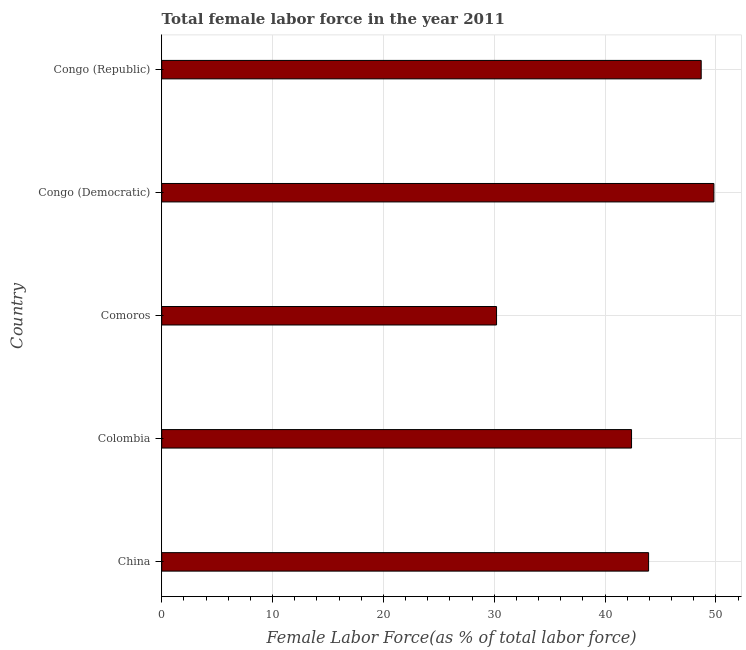Does the graph contain grids?
Your response must be concise. Yes. What is the title of the graph?
Offer a very short reply. Total female labor force in the year 2011. What is the label or title of the X-axis?
Give a very brief answer. Female Labor Force(as % of total labor force). What is the label or title of the Y-axis?
Your response must be concise. Country. What is the total female labor force in China?
Make the answer very short. 43.92. Across all countries, what is the maximum total female labor force?
Give a very brief answer. 49.81. Across all countries, what is the minimum total female labor force?
Keep it short and to the point. 30.21. In which country was the total female labor force maximum?
Provide a succinct answer. Congo (Democratic). In which country was the total female labor force minimum?
Offer a terse response. Comoros. What is the sum of the total female labor force?
Your answer should be compact. 214.99. What is the difference between the total female labor force in Colombia and Congo (Republic)?
Offer a terse response. -6.28. What is the average total female labor force per country?
Your response must be concise. 43. What is the median total female labor force?
Make the answer very short. 43.92. What is the ratio of the total female labor force in Comoros to that in Congo (Republic)?
Make the answer very short. 0.62. Is the total female labor force in Colombia less than that in Comoros?
Make the answer very short. No. What is the difference between the highest and the second highest total female labor force?
Make the answer very short. 1.14. What is the difference between the highest and the lowest total female labor force?
Offer a very short reply. 19.61. In how many countries, is the total female labor force greater than the average total female labor force taken over all countries?
Offer a terse response. 3. What is the difference between two consecutive major ticks on the X-axis?
Ensure brevity in your answer.  10. What is the Female Labor Force(as % of total labor force) in China?
Your answer should be compact. 43.92. What is the Female Labor Force(as % of total labor force) in Colombia?
Your answer should be compact. 42.38. What is the Female Labor Force(as % of total labor force) of Comoros?
Offer a very short reply. 30.21. What is the Female Labor Force(as % of total labor force) in Congo (Democratic)?
Offer a terse response. 49.81. What is the Female Labor Force(as % of total labor force) in Congo (Republic)?
Give a very brief answer. 48.67. What is the difference between the Female Labor Force(as % of total labor force) in China and Colombia?
Offer a terse response. 1.54. What is the difference between the Female Labor Force(as % of total labor force) in China and Comoros?
Keep it short and to the point. 13.72. What is the difference between the Female Labor Force(as % of total labor force) in China and Congo (Democratic)?
Provide a succinct answer. -5.89. What is the difference between the Female Labor Force(as % of total labor force) in China and Congo (Republic)?
Your answer should be compact. -4.75. What is the difference between the Female Labor Force(as % of total labor force) in Colombia and Comoros?
Give a very brief answer. 12.18. What is the difference between the Female Labor Force(as % of total labor force) in Colombia and Congo (Democratic)?
Offer a very short reply. -7.43. What is the difference between the Female Labor Force(as % of total labor force) in Colombia and Congo (Republic)?
Your response must be concise. -6.28. What is the difference between the Female Labor Force(as % of total labor force) in Comoros and Congo (Democratic)?
Make the answer very short. -19.61. What is the difference between the Female Labor Force(as % of total labor force) in Comoros and Congo (Republic)?
Provide a succinct answer. -18.46. What is the difference between the Female Labor Force(as % of total labor force) in Congo (Democratic) and Congo (Republic)?
Give a very brief answer. 1.14. What is the ratio of the Female Labor Force(as % of total labor force) in China to that in Colombia?
Ensure brevity in your answer.  1.04. What is the ratio of the Female Labor Force(as % of total labor force) in China to that in Comoros?
Your answer should be compact. 1.45. What is the ratio of the Female Labor Force(as % of total labor force) in China to that in Congo (Democratic)?
Provide a short and direct response. 0.88. What is the ratio of the Female Labor Force(as % of total labor force) in China to that in Congo (Republic)?
Keep it short and to the point. 0.9. What is the ratio of the Female Labor Force(as % of total labor force) in Colombia to that in Comoros?
Provide a short and direct response. 1.4. What is the ratio of the Female Labor Force(as % of total labor force) in Colombia to that in Congo (Democratic)?
Give a very brief answer. 0.85. What is the ratio of the Female Labor Force(as % of total labor force) in Colombia to that in Congo (Republic)?
Your answer should be compact. 0.87. What is the ratio of the Female Labor Force(as % of total labor force) in Comoros to that in Congo (Democratic)?
Provide a short and direct response. 0.61. What is the ratio of the Female Labor Force(as % of total labor force) in Comoros to that in Congo (Republic)?
Provide a short and direct response. 0.62. What is the ratio of the Female Labor Force(as % of total labor force) in Congo (Democratic) to that in Congo (Republic)?
Give a very brief answer. 1.02. 